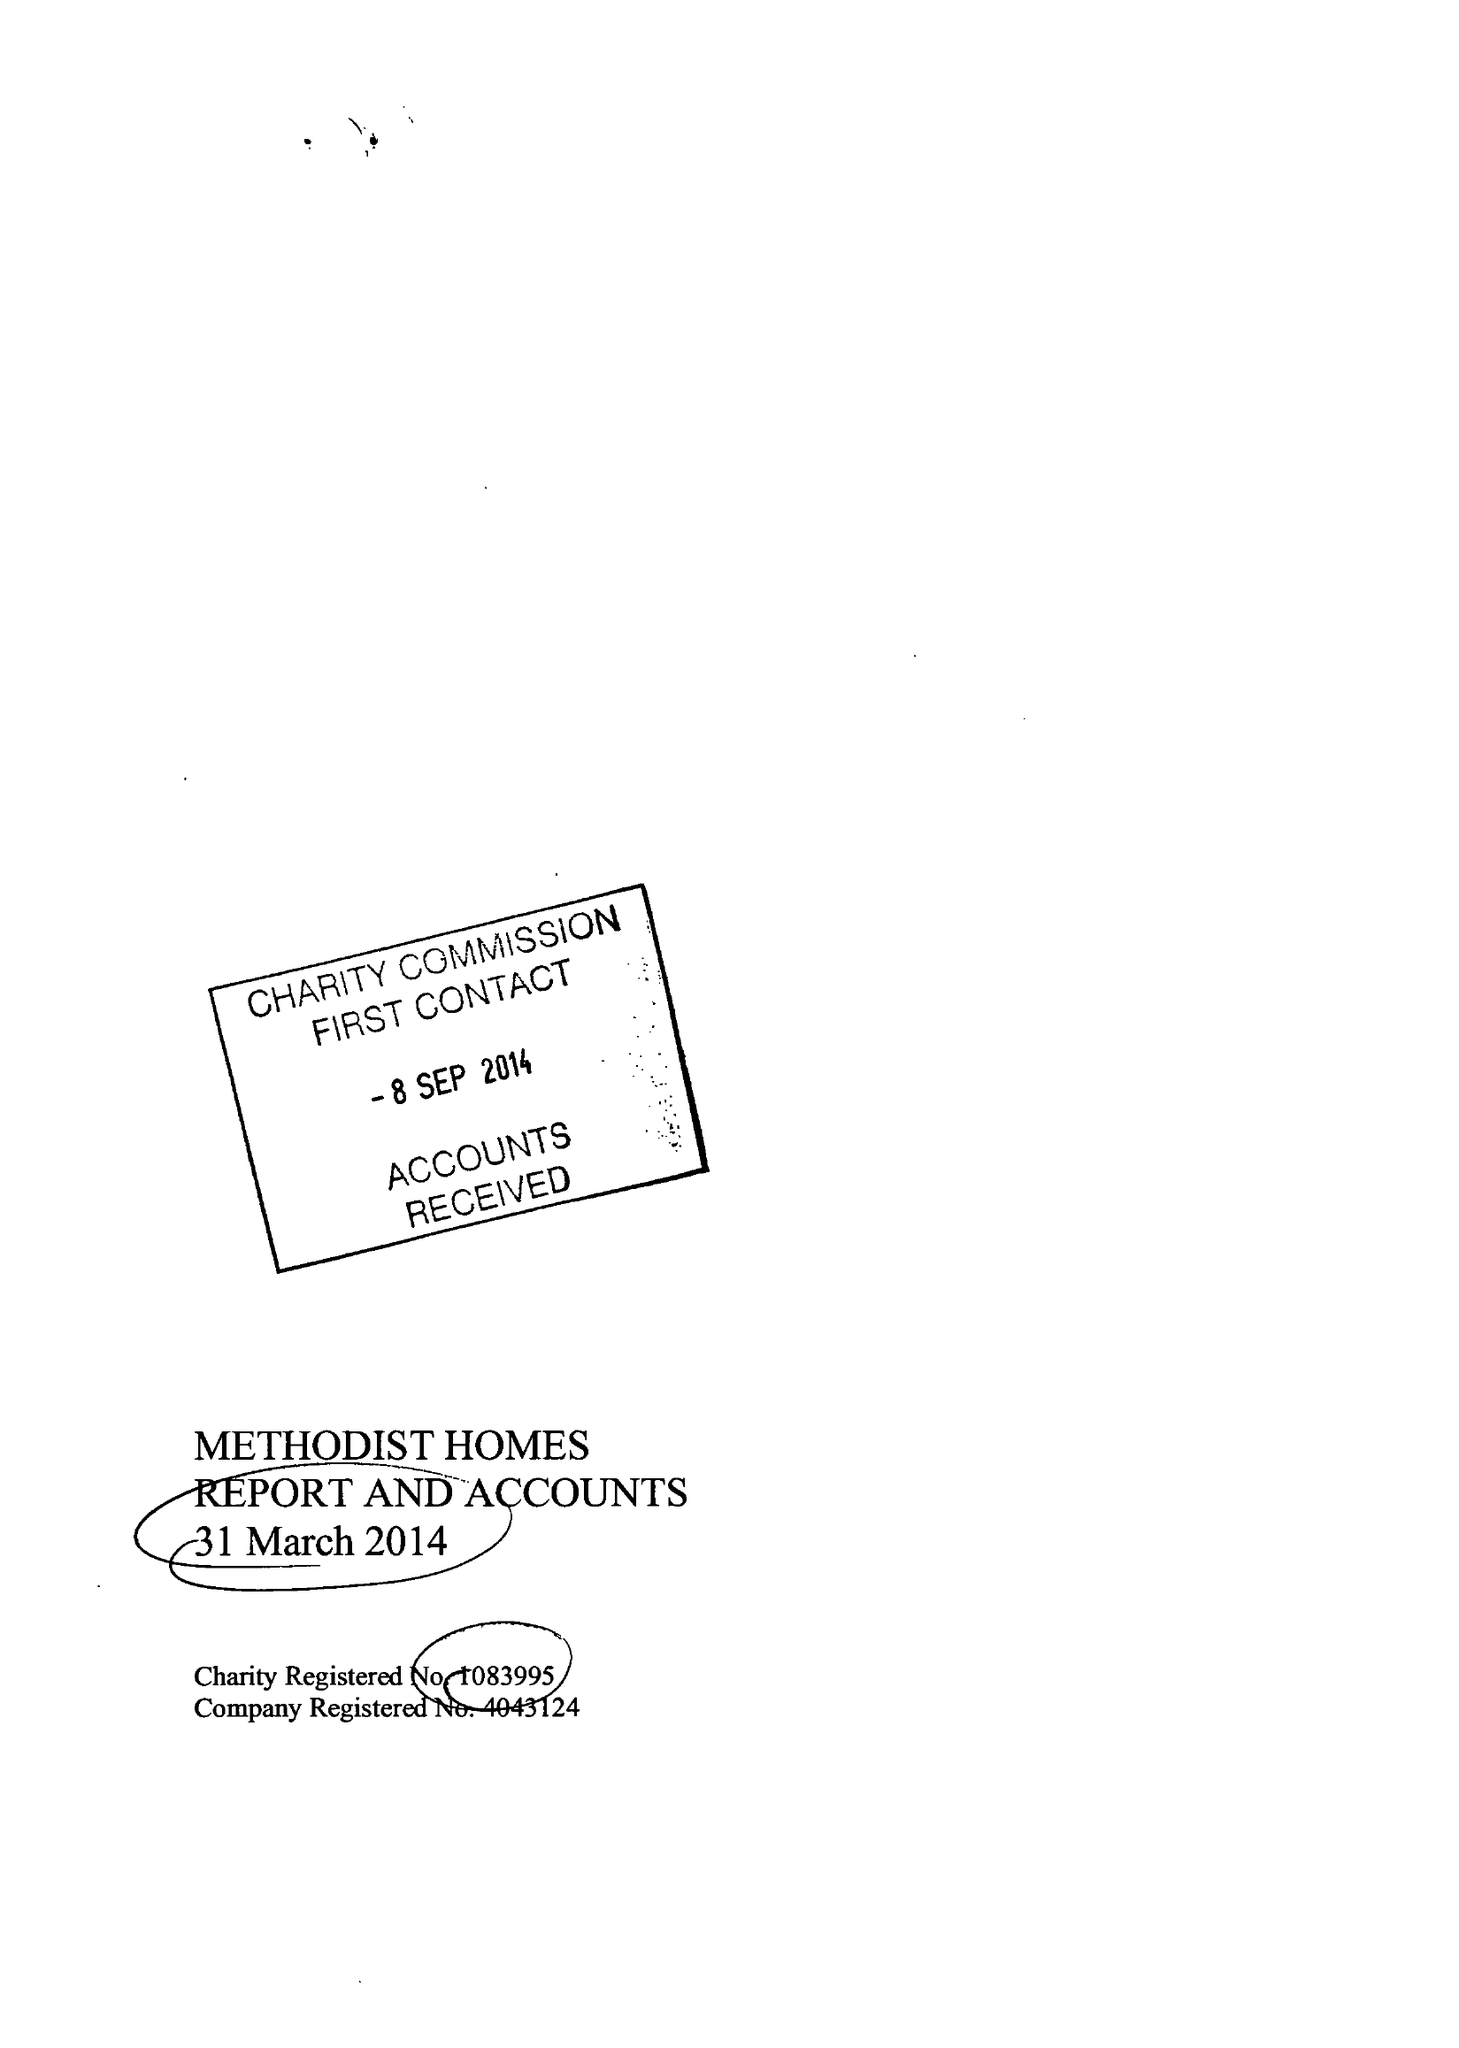What is the value for the spending_annually_in_british_pounds?
Answer the question using a single word or phrase. 185701000.00 